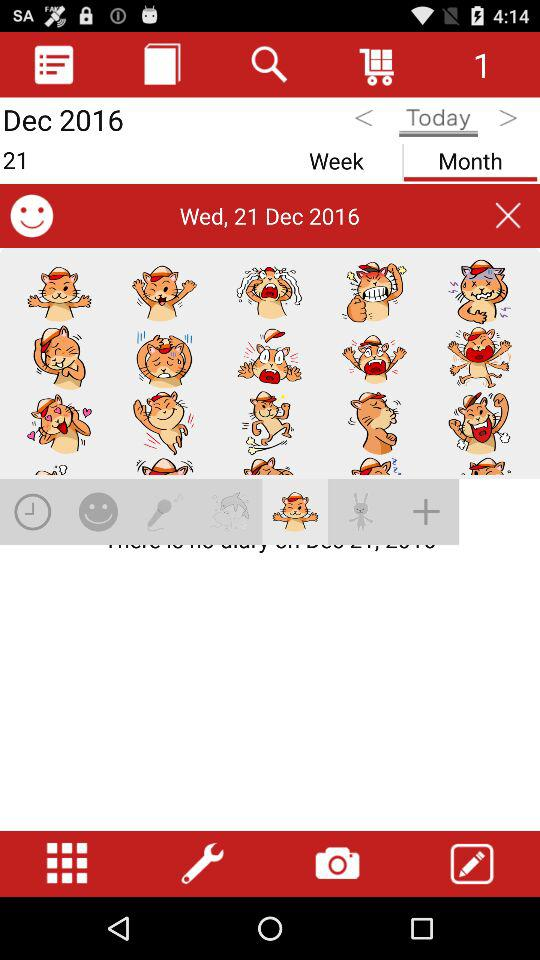Which is the selected month? The selected month is December. 